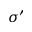Convert formula to latex. <formula><loc_0><loc_0><loc_500><loc_500>\sigma ^ { \prime }</formula> 